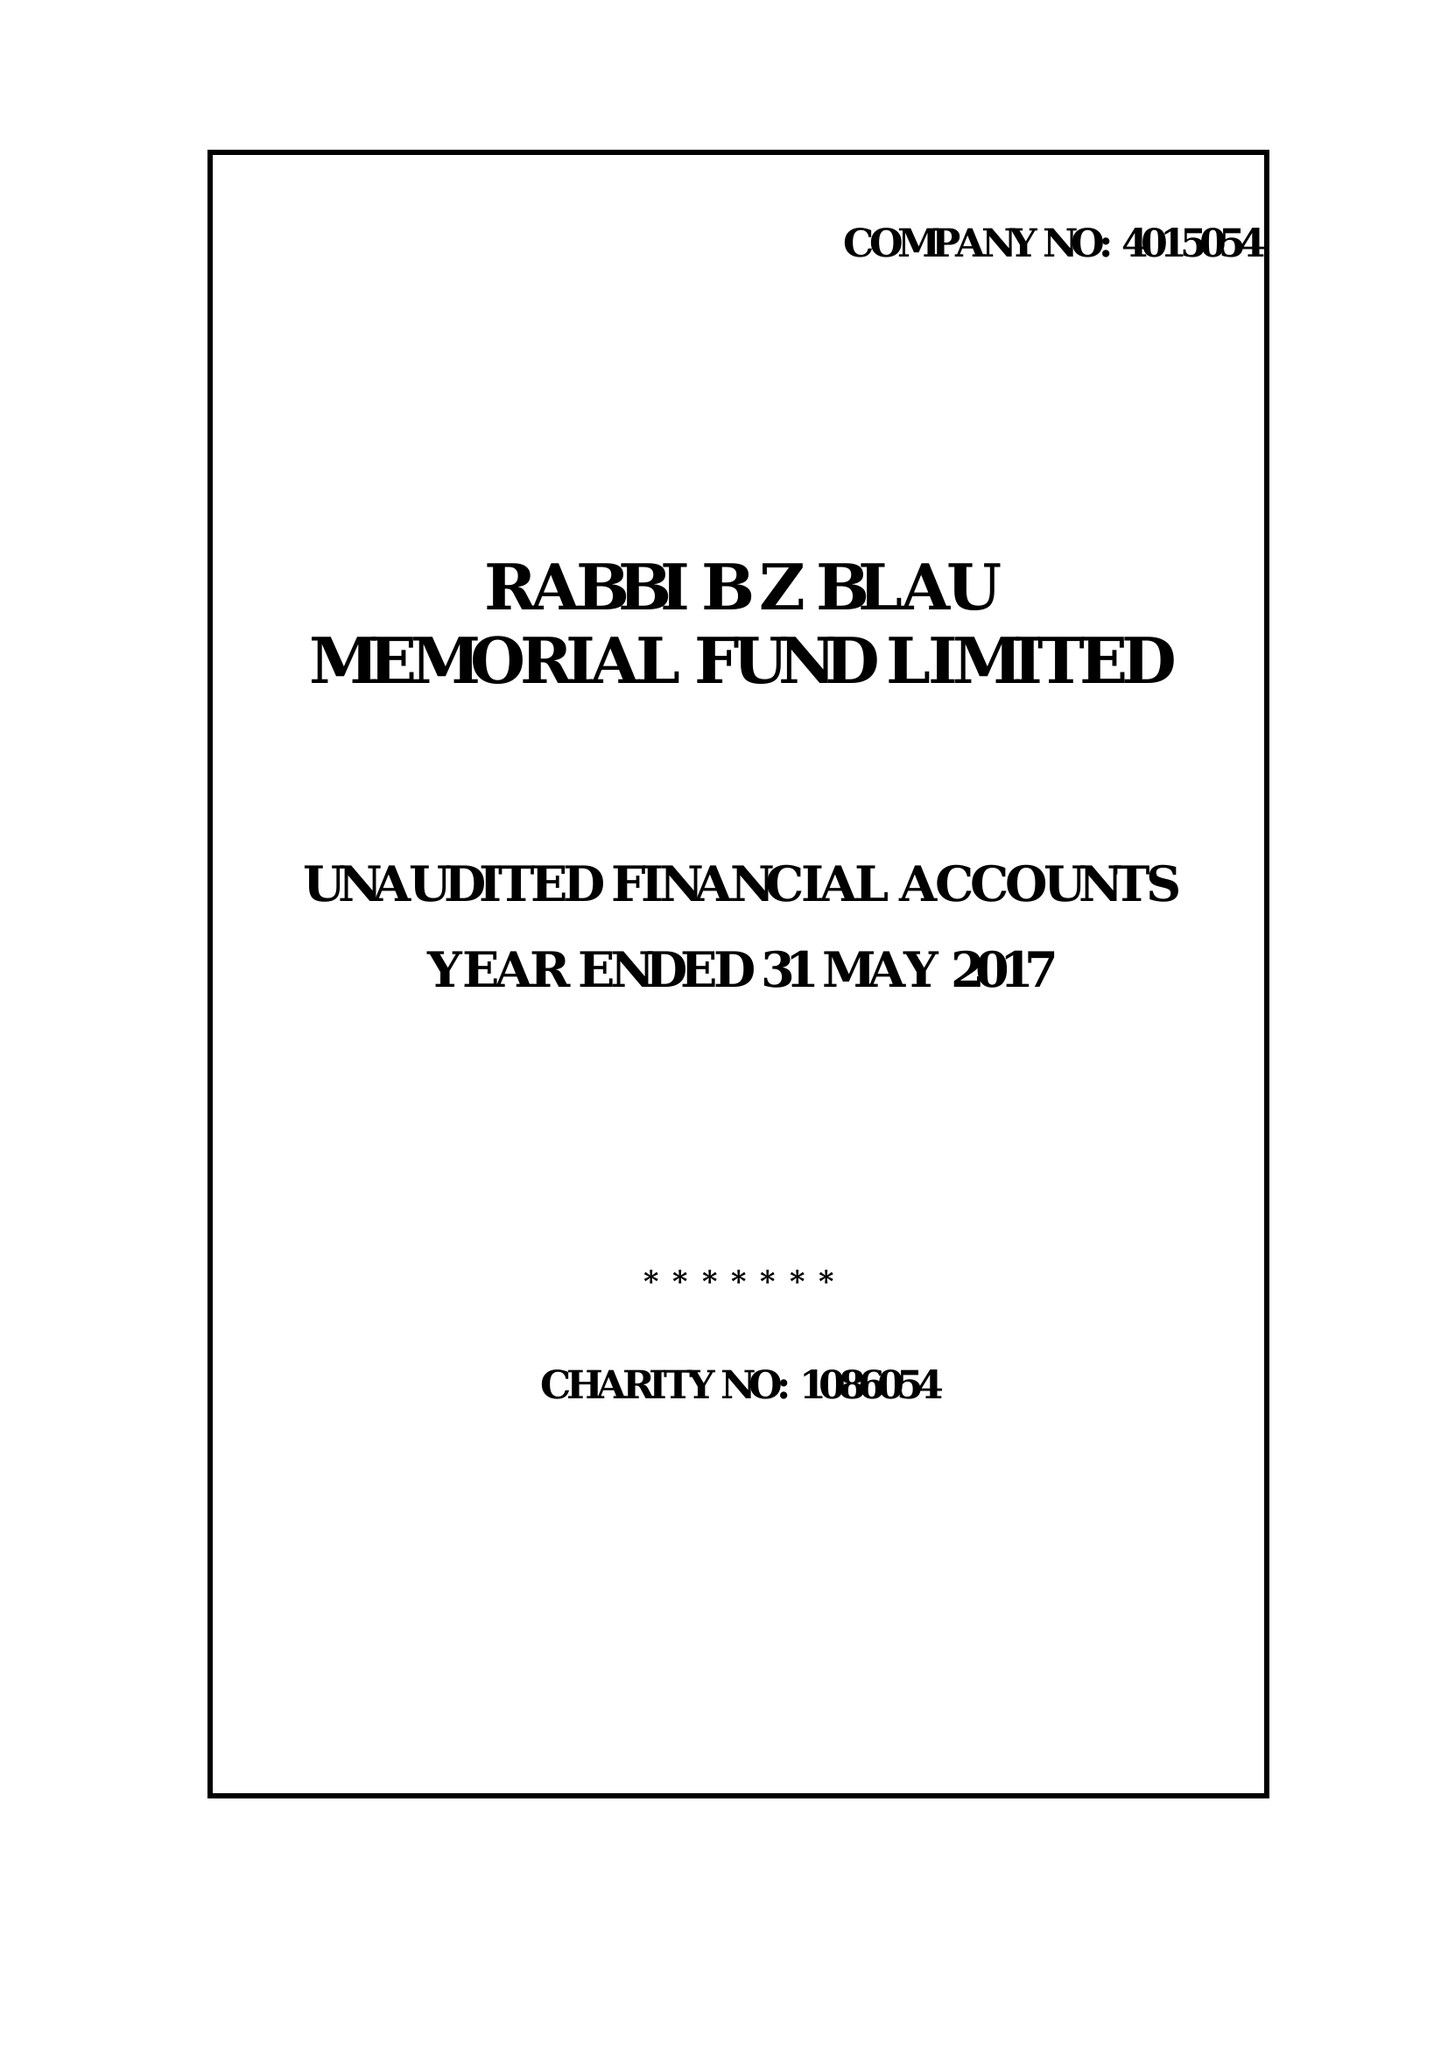What is the value for the address__post_town?
Answer the question using a single word or phrase. LONDON 